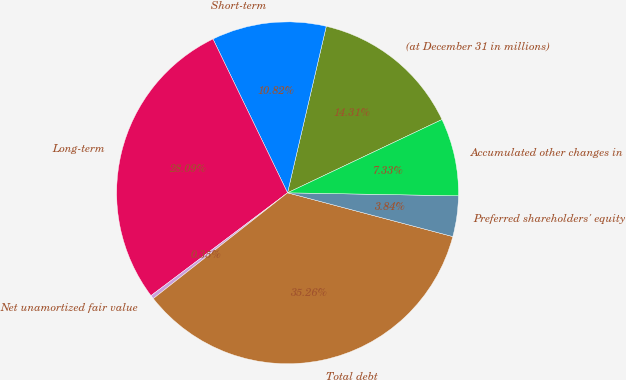Convert chart to OTSL. <chart><loc_0><loc_0><loc_500><loc_500><pie_chart><fcel>(at December 31 in millions)<fcel>Short-term<fcel>Long-term<fcel>Net unamortized fair value<fcel>Total debt<fcel>Preferred shareholders' equity<fcel>Accumulated other changes in<nl><fcel>14.31%<fcel>10.82%<fcel>28.08%<fcel>0.35%<fcel>35.25%<fcel>3.84%<fcel>7.33%<nl></chart> 